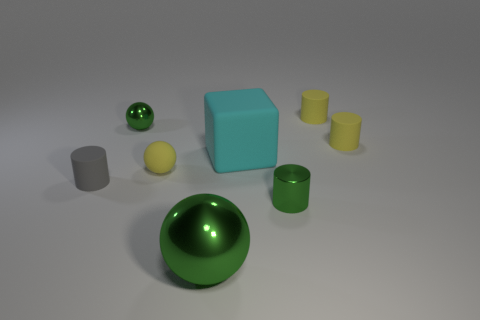There is a tiny sphere that is the same color as the shiny cylinder; what material is it? If the tiny sphere shares the same color and sheen as the shiny cylinder, it's likely they are both made of a similar metallic material, given the reflective properties and luster we can observe. 